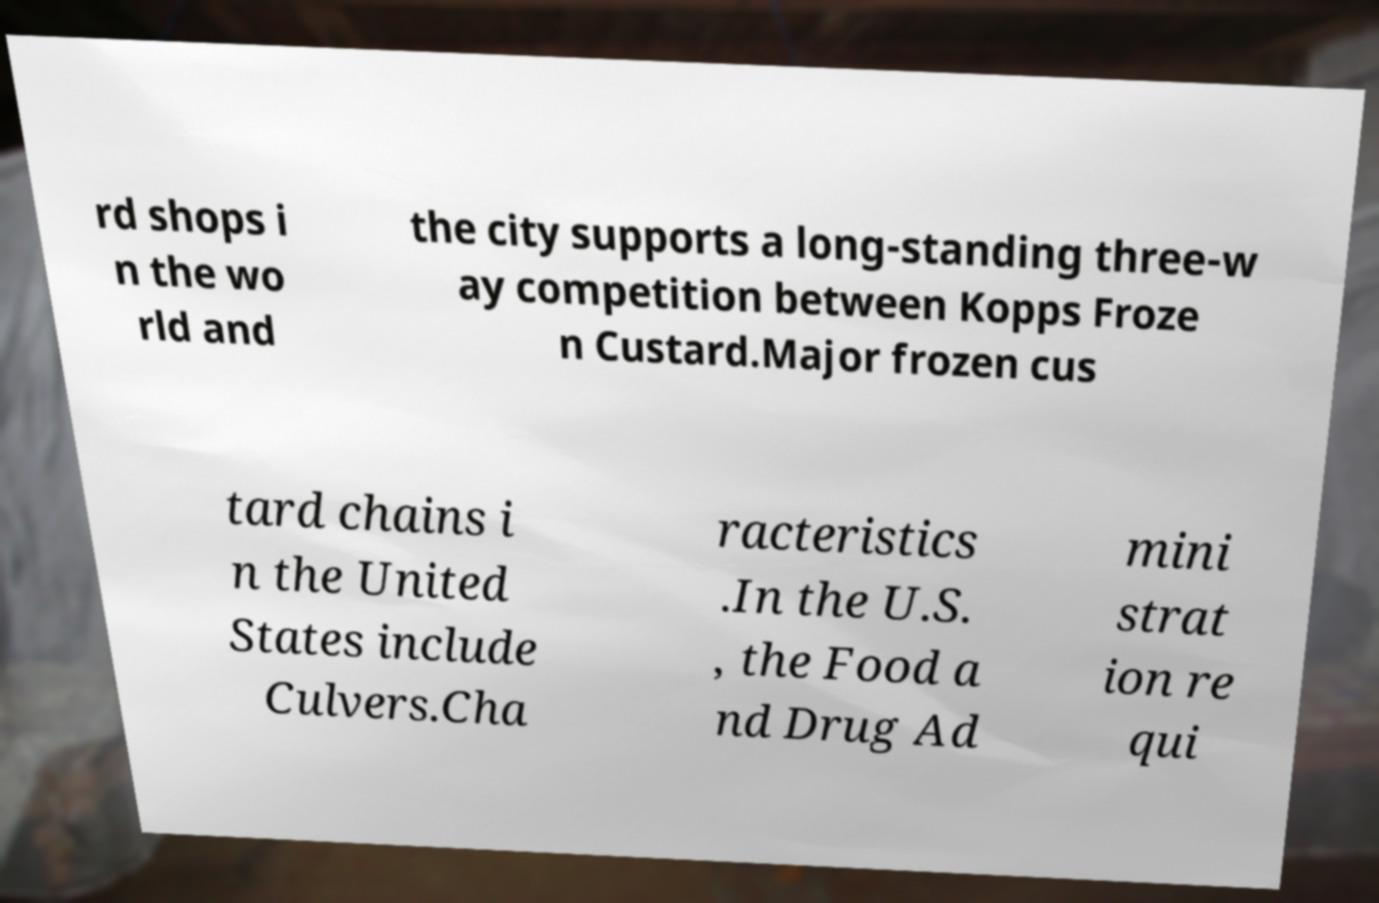Can you read and provide the text displayed in the image?This photo seems to have some interesting text. Can you extract and type it out for me? rd shops i n the wo rld and the city supports a long-standing three-w ay competition between Kopps Froze n Custard.Major frozen cus tard chains i n the United States include Culvers.Cha racteristics .In the U.S. , the Food a nd Drug Ad mini strat ion re qui 